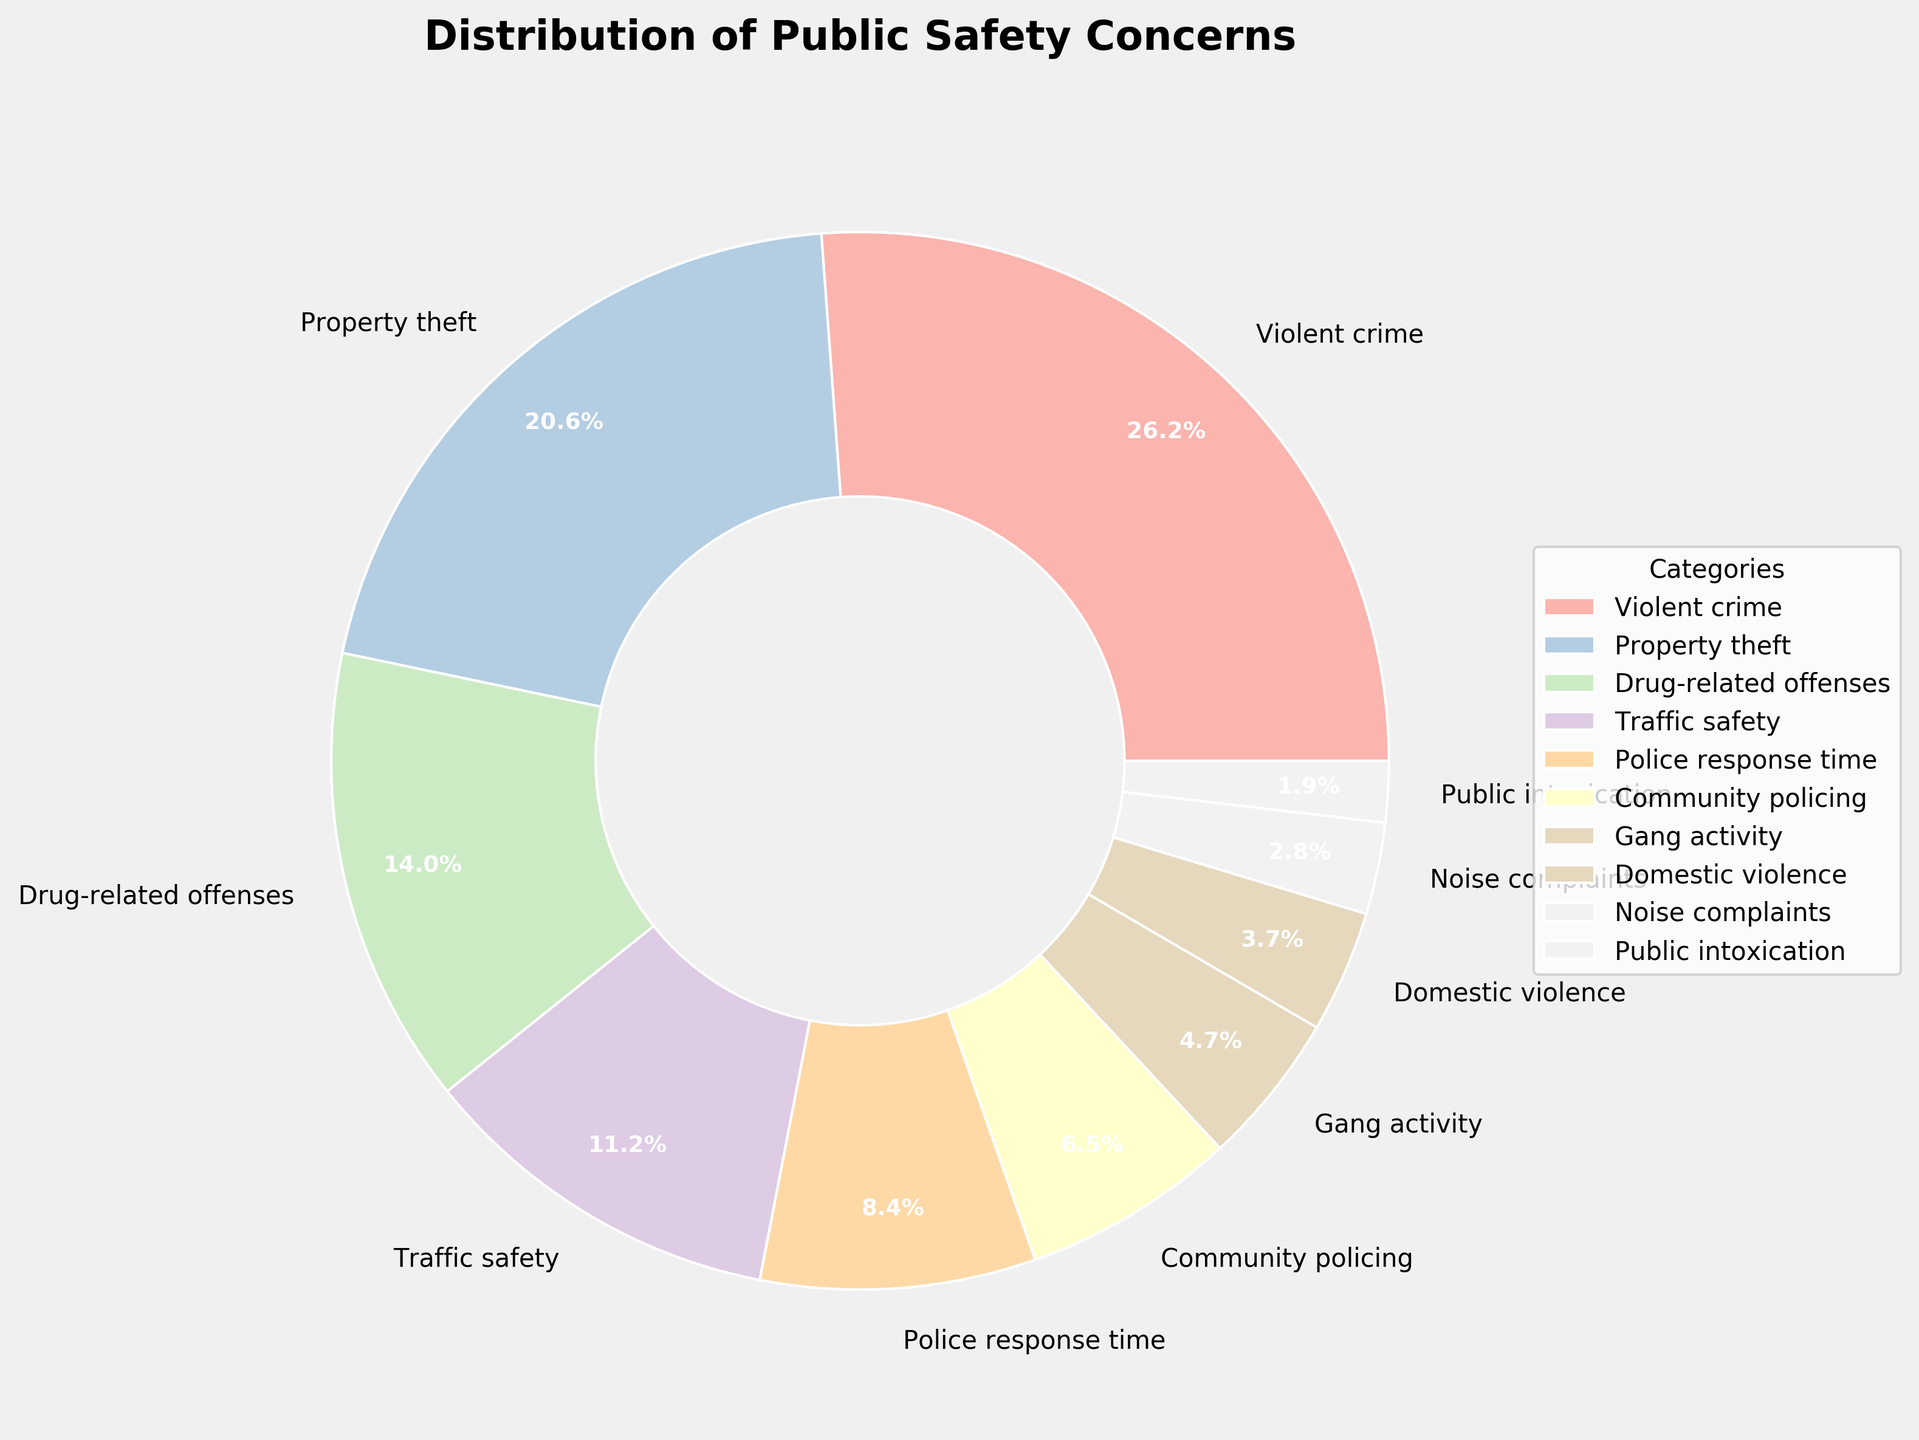What percentage of residents expressed concern about traffic safety? To determine the percentage of residents concerned about traffic safety, simply look at the segment of the pie chart labeled "Traffic safety." The percentage value is provided there.
Answer: 12% What is the total percentage of residents concerned about property theft and drug-related offenses combined? Add the percentages from the segments labeled "Property theft" and "Drug-related offenses." They are 22% and 15% respectively. So, 22% + 15% = 37%.
Answer: 37% Which category has a higher percentage of concerns, community policing or gang activity? Compare the percentages of concerns from the segments labeled "Community policing" and "Gang activity." Community policing has 7%, and gang activity has 5%. 7% is greater than 5%, so community policing has more concerns.
Answer: Community policing What is the difference in the percentage of concerns between police response time and noise complaints? Subtract the percentage of noise complaints from the percentage of police response time. Police response time is 9%, and noise complaints are 3%. So, 9% - 3% = 6%.
Answer: 6% How many categories have a concern percentage of 10% or higher? Identify the categories with percentages of 10% or higher by looking at the pie chart. The qualifying categories are "Violent crime" (28%), "Property theft" (22%), "Drug-related offenses" (15%), and "Traffic safety" (12%), totaling 4 categories.
Answer: 4 Which category is the least concerning to residents, and what is its percentage? Determine the smallest segment in the pie chart and identify its label and percentage. The smallest segment is "Public intoxication" with 2%.
Answer: Public intoxication, 2% What is the combined percentage of residents concerned about violent crime, gang activity, and domestic violence? Add the percentages from the segments labeled "Violent crime," "Gang activity," and "Domestic violence." The percentages are 28%, 5%, and 4% respectively. So, 28% + 5% + 4% = 37%.
Answer: 37% What is the visual relationship between property theft and drug-related offenses in the pie chart? Visually, the segment for property theft is larger than that for drug-related offenses. This indicates a higher percentage for property theft (22%) compared to drug-related offenses (15%).
Answer: Property theft is larger 